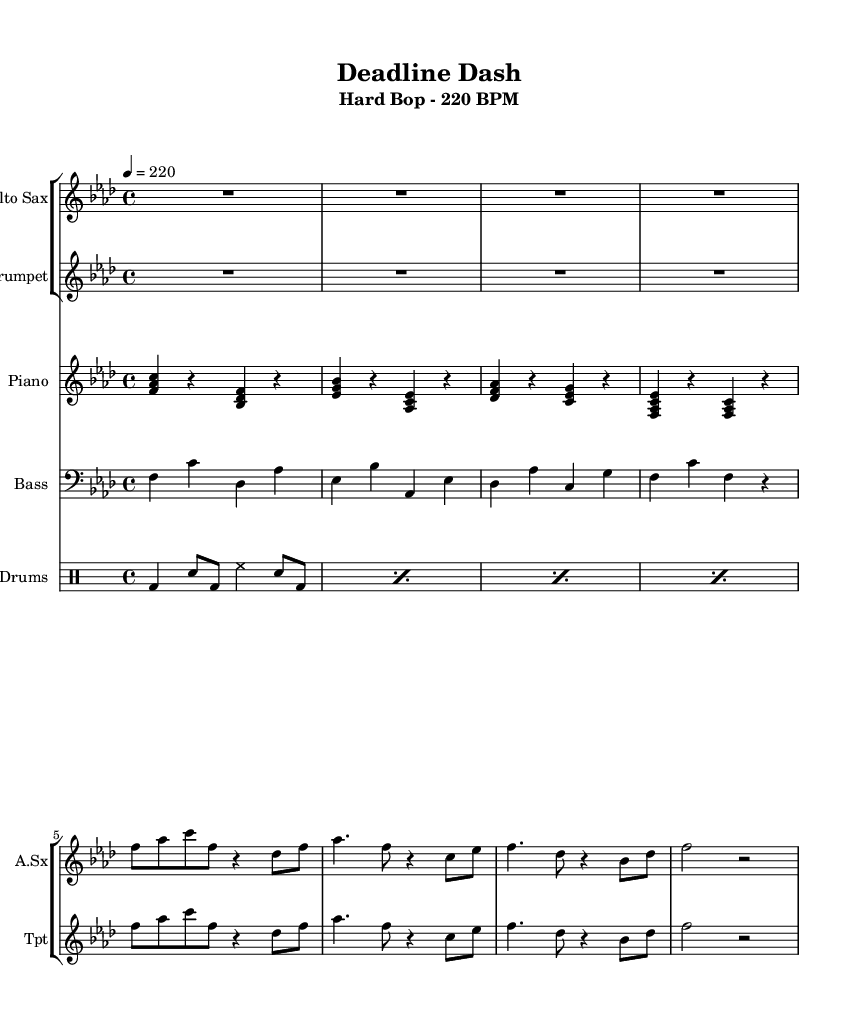What is the key signature of this music? The key signature is indicated in the staff, where there are four flats present. This corresponds to the key of F minor.
Answer: F minor What is the time signature of this music? The time signature appears at the beginning of the sheet music and is indicated as 4/4, which means there are four beats in a measure, and the quarter note gets one beat.
Answer: 4/4 What is the tempo of the piece? The tempo is marked above the staff and is indicated as 220 beats per minute (BPM), which is quite fast and energetic.
Answer: 220 BPM How many measures are in the piece? By analyzing the music, we can count the number of complete measures based on the notation; the section for the alto sax and trumpet indicates that there are four measures in total.
Answer: 4 Which instrument plays the main melodic line in this excerpt? The music shows two staves for the alto sax and trumpet; both visually align with similar melodic patterns, suggesting that they are carrying the main themes in unison. However, since they share the line and no specific instrument is favored over the other, either can be considered as playing the primary melody.
Answer: Alto Sax or Trumpet What type of jazz does this tune represent? This piece falls into the hard bop style, characterized by its energetic rhythms and use of complex chords, which aligns with the hard bop tradition evident in the fast tempo and the expressive nature of the melodies.
Answer: Hard Bop Which percussion instrument is featured prominently in the rhythm section? The drum patterns in the notation indicate the use of a bass drum (bd) and snare (sn), which are standard in jazz drumming, highlighting its role in maintaining the energetic drive of the piece.
Answer: Drums 